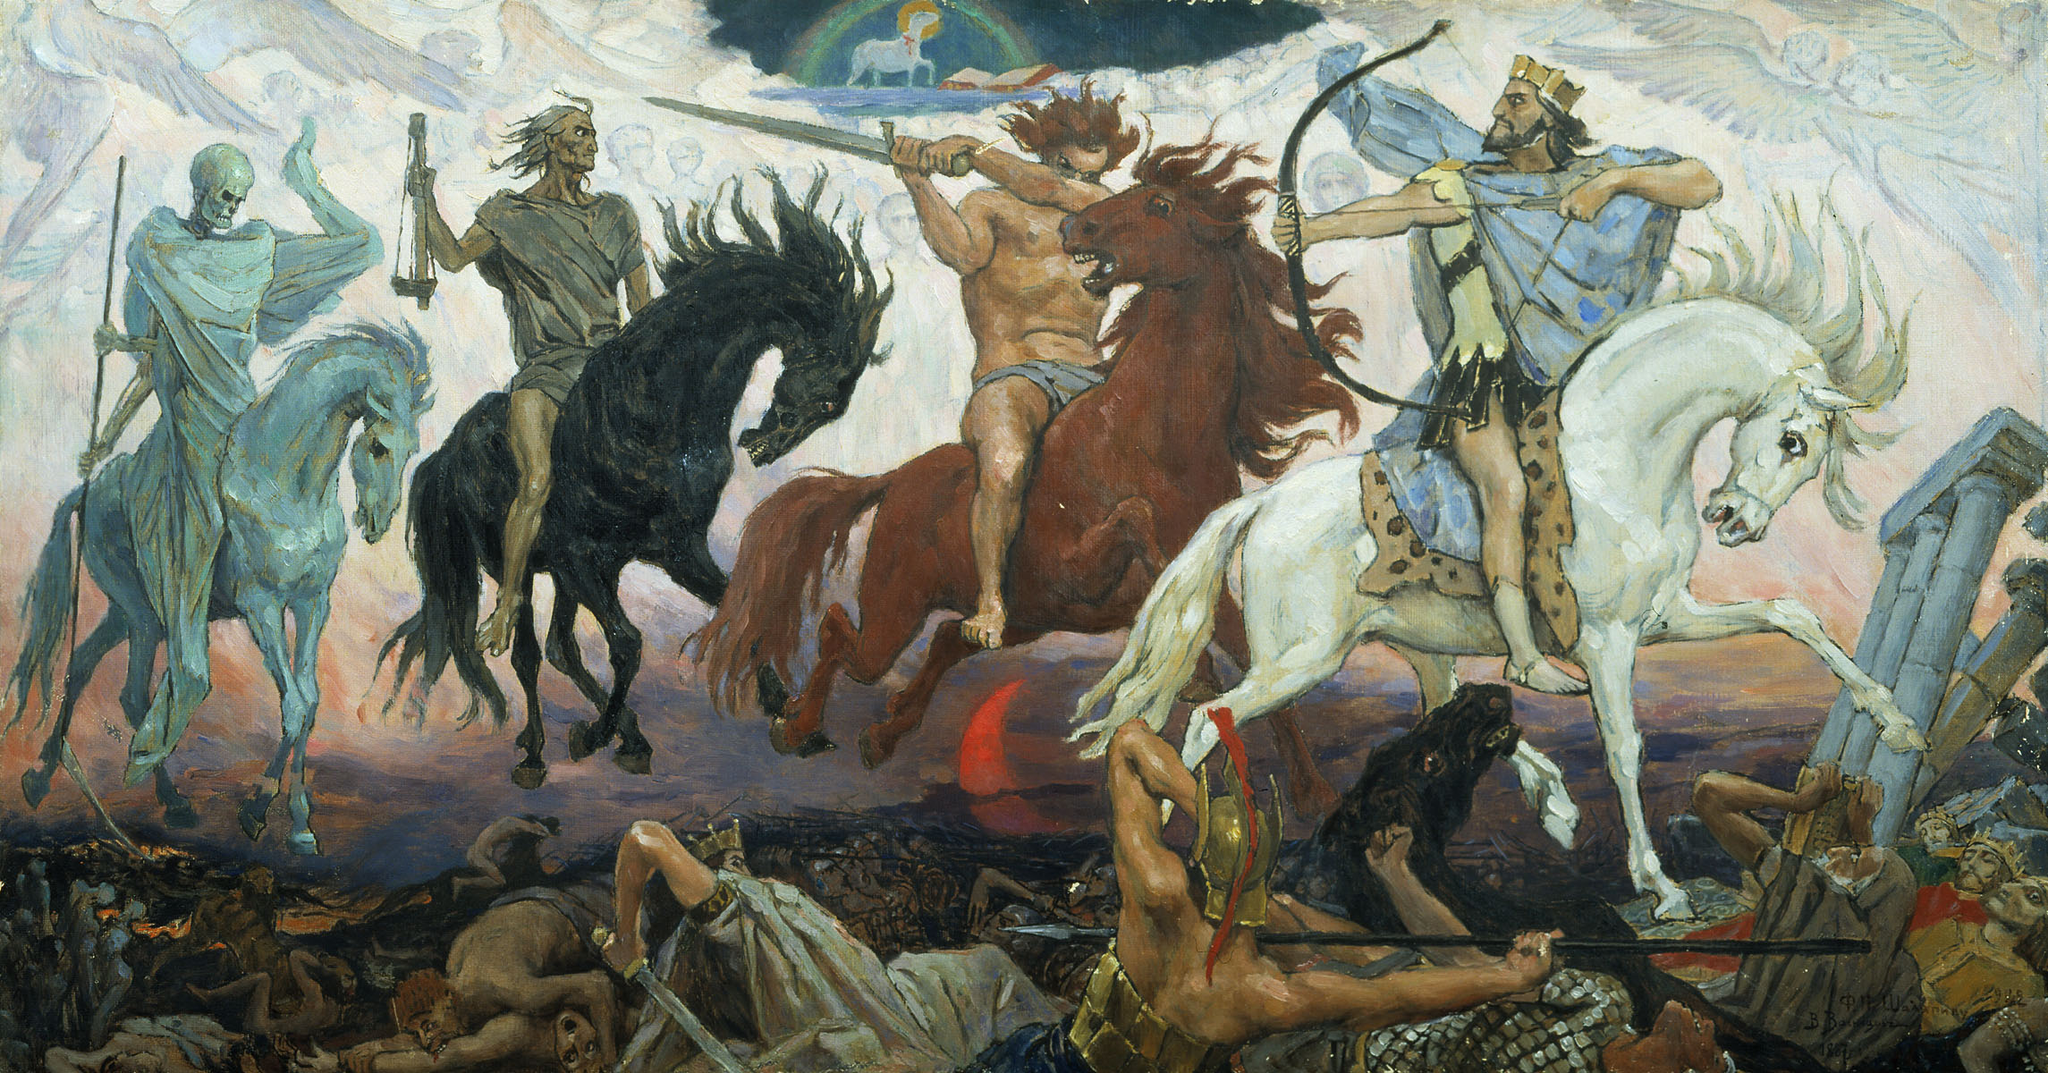Based on the image, what atmospheric elements contribute to the feelings evoked? The swirling clouds and ethereal figures in the background contribute to a sense of otherworldliness and impending doom. The play of light and shadow enhances the dramatic tension, especially with the contrasting colors of the horsemen and their horses. The chaotic scene below, with panicked figures and fallen bodies, further amplifies the sense of disaster. These atmospheric elements together evoke feelings of fear, awe, and contemplation about the themes of apocalypse and judgment. 